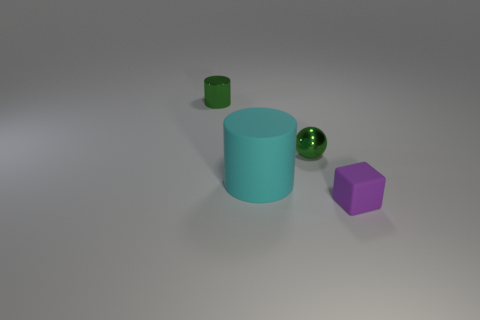What shape is the cyan matte thing?
Offer a terse response. Cylinder. There is a shiny object on the right side of the rubber thing behind the purple block; how big is it?
Provide a succinct answer. Small. Is the number of big cyan matte cylinders that are left of the cyan thing the same as the number of objects to the right of the block?
Make the answer very short. Yes. What is the tiny object that is on the right side of the large rubber cylinder and behind the cube made of?
Offer a terse response. Metal. Is the size of the purple rubber cube the same as the green thing right of the large cylinder?
Your answer should be very brief. Yes. What number of other things are there of the same color as the big matte cylinder?
Your response must be concise. 0. Is the number of green things in front of the purple cube greater than the number of cyan rubber things?
Make the answer very short. No. What is the color of the metallic thing that is to the left of the small green metallic object that is to the right of the matte object behind the tiny rubber object?
Offer a terse response. Green. Do the small green sphere and the purple thing have the same material?
Give a very brief answer. No. Is there a blue shiny thing that has the same size as the cyan object?
Keep it short and to the point. No. 